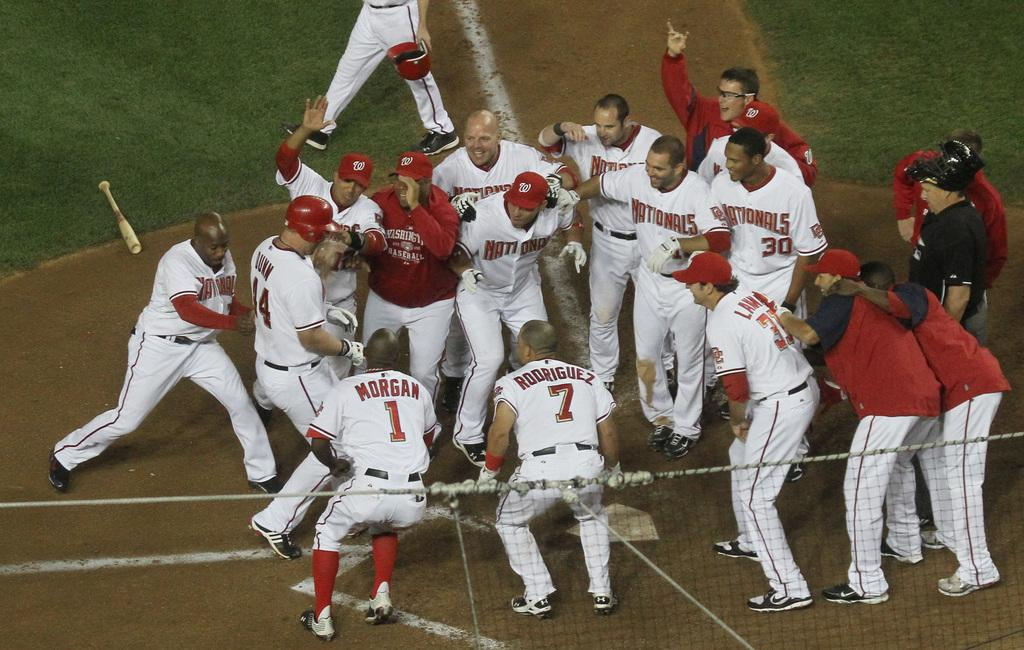Provide a one-sentence caption for the provided image. Morgan, Rodriguez and a bunch of other baseball players hug, clap and celebrate together. 